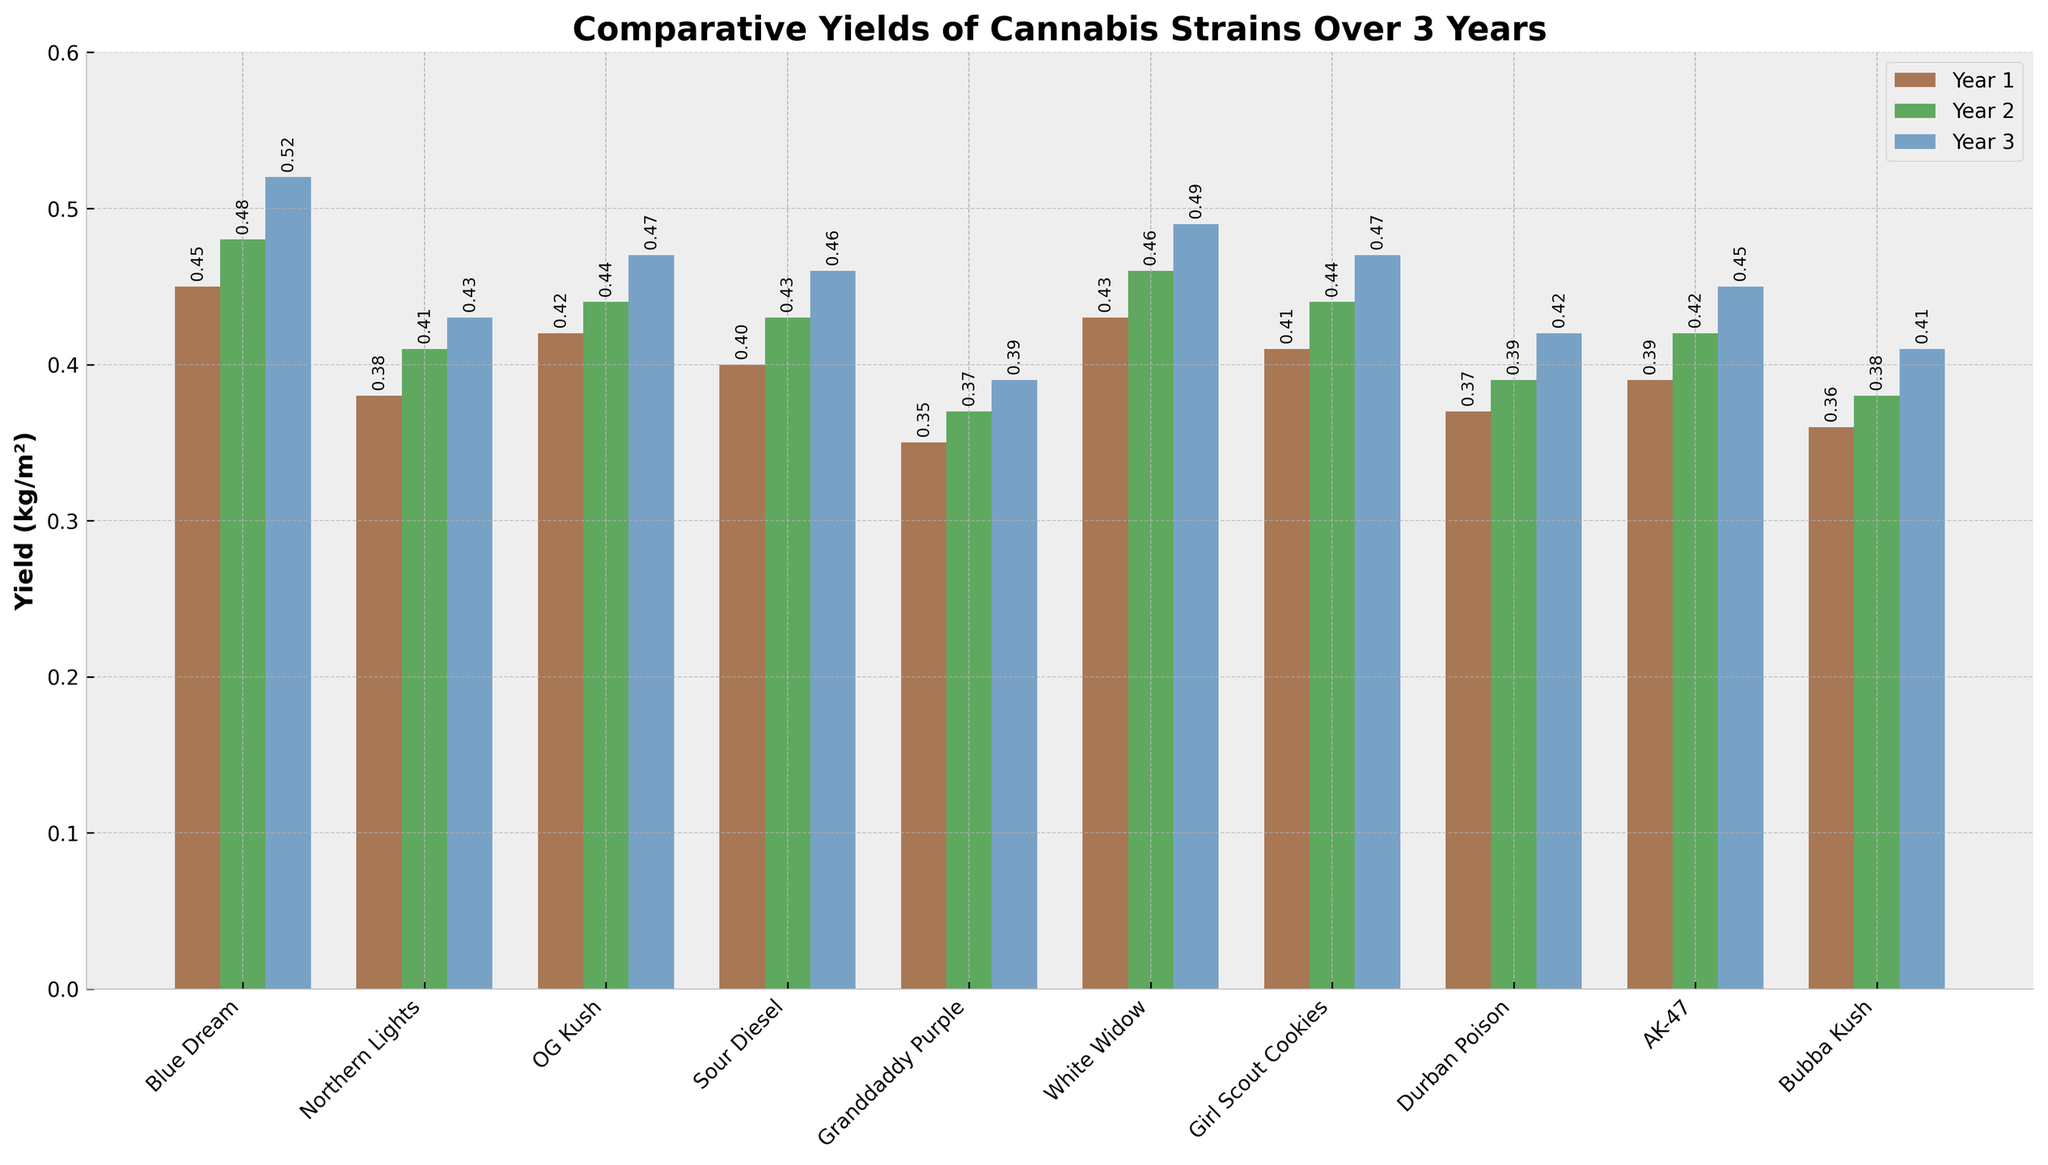Which strain had the highest yield in Year 3? Identify the tallest bar in the Year 3 group, which is blue, and find its corresponding strain on the x-axis.
Answer: Blue Dream What is the total yield of OG Kush over the three years? Sum the yields of OG Kush across all three years: 0.42 (Year 1) + 0.44 (Year 2) + 0.47 (Year 3) = 1.33 kg/m².
Answer: 1.33 kg/m² Which strain had the most consistent (least variation) yield across the three years? Calculate the range of yields (max-min) for each strain and compare them. The smallest range indicates the most consistent yield.
Answer: Granddaddy Purple (range is 0.04) Which year had the highest average yield across all strains? Calculate the average yield of all strains for each year and compare: (Sum of all yields in Year 1)/10, (Sum of all yields in Year 2)/10, (Sum of all yields in Year 3)/10. Year 3 has the highest average.
Answer: Year 3 How did the yield of White Widow change from Year 1 to Year 3? Subtract the Year 1 yield of White Widow from its Year 3 yield: 0.49 (Year 3) - 0.43 (Year 1) = 0.06 kg/m² increase.
Answer: 0.06 kg/m² increase Which strain showed the highest improvement in yield from Year 1 to Year 2? Calculate the yield difference from Year 1 to Year 2 for each strain and find the maximum: Blue Dream had the largest increase (0.48 - 0.45 = 0.03 kg/m²).
Answer: Blue Dream How many strains exceeded a yield of 0.4 kg/m² in Year 1? Count the number of bars in the Year 1 group that have heights greater than 0.4. These strains are Blue Dream, OG Kush, White Widow, Girl Scout Cookies, and AK-47.
Answer: 5 strains Which strain had a yield below 0.4 kg/m² in all three years? Identify the strains where all three bars (heights) are below 0.4. Granddaddy Purple fits this criterion.
Answer: Granddaddy Purple Compare the yields of Northern Lights and Bubba Kush in Year 2. Which one is higher? Find the heights of the green bars for Northern Lights and Bubba Kush in Year 2 and compare them: Northern Lights (0.41) > Bubba Kush (0.38).
Answer: Northern Lights Summarize the overall trend in yields from Year 1 to Year 3 for all strains collectively. Observe the heights of the bars across the years for all strains. Most bars tend to get taller, indicating an overall increase in yield over the three years.
Answer: Increasing trend 